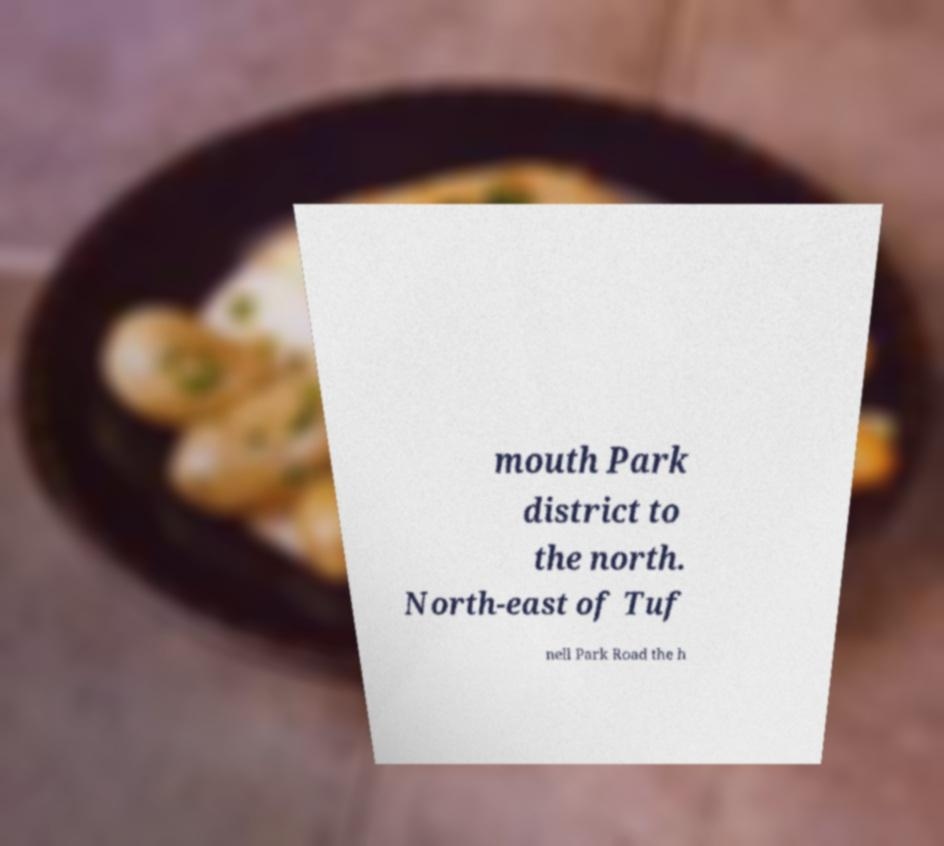Could you assist in decoding the text presented in this image and type it out clearly? mouth Park district to the north. North-east of Tuf nell Park Road the h 